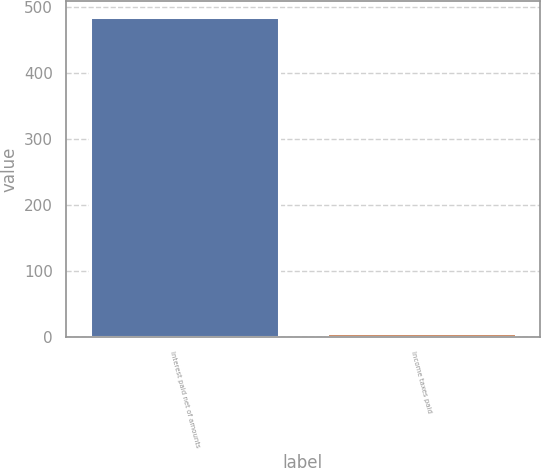<chart> <loc_0><loc_0><loc_500><loc_500><bar_chart><fcel>Interest paid net of amounts<fcel>Income taxes paid<nl><fcel>485<fcel>6<nl></chart> 